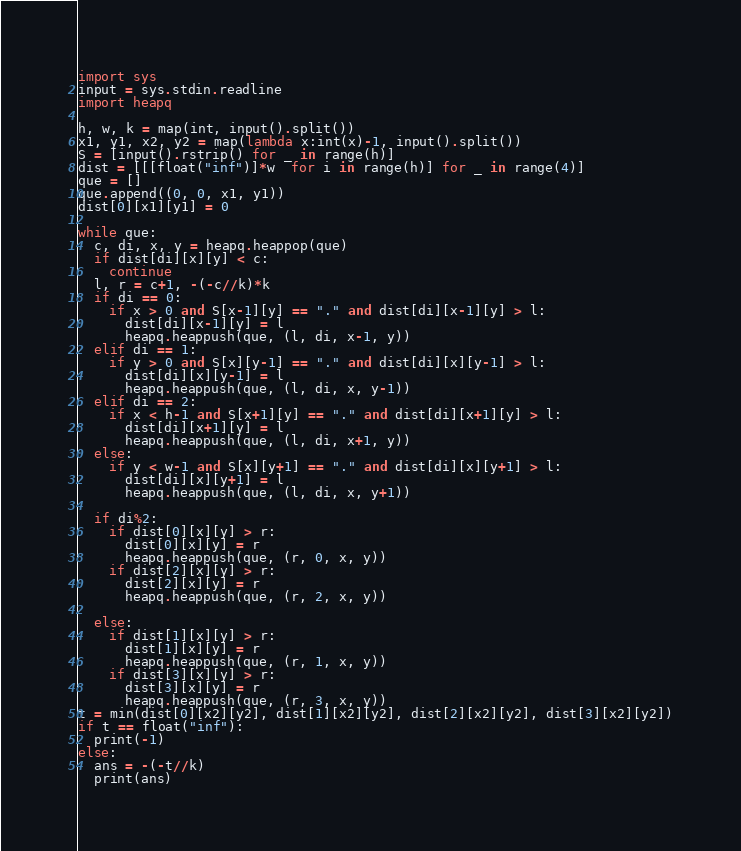<code> <loc_0><loc_0><loc_500><loc_500><_Python_>import sys
input = sys.stdin.readline
import heapq

h, w, k = map(int, input().split())
x1, y1, x2, y2 = map(lambda x:int(x)-1, input().split())
S = [input().rstrip() for _ in range(h)]
dist = [[[float("inf")]*w  for i in range(h)] for _ in range(4)]
que = []
que.append((0, 0, x1, y1))
dist[0][x1][y1] = 0
  
while que:
  c, di, x, y = heapq.heappop(que)
  if dist[di][x][y] < c:
    continue
  l, r = c+1, -(-c//k)*k
  if di == 0:
    if x > 0 and S[x-1][y] == "." and dist[di][x-1][y] > l:
      dist[di][x-1][y] = l
      heapq.heappush(que, (l, di, x-1, y))
  elif di == 1:
    if y > 0 and S[x][y-1] == "." and dist[di][x][y-1] > l:
      dist[di][x][y-1] = l
      heapq.heappush(que, (l, di, x, y-1))
  elif di == 2:
    if x < h-1 and S[x+1][y] == "." and dist[di][x+1][y] > l:
      dist[di][x+1][y] = l
      heapq.heappush(que, (l, di, x+1, y))
  else:
    if y < w-1 and S[x][y+1] == "." and dist[di][x][y+1] > l:
      dist[di][x][y+1] = l
      heapq.heappush(que, (l, di, x, y+1))
      
  if di%2:
    if dist[0][x][y] > r:
      dist[0][x][y] = r
      heapq.heappush(que, (r, 0, x, y))
    if dist[2][x][y] > r:
      dist[2][x][y] = r
      heapq.heappush(que, (r, 2, x, y))
    
  else:
    if dist[1][x][y] > r:
      dist[1][x][y] = r
      heapq.heappush(que, (r, 1, x, y))
    if dist[3][x][y] > r:
      dist[3][x][y] = r
      heapq.heappush(que, (r, 3, x, y))
t = min(dist[0][x2][y2], dist[1][x2][y2], dist[2][x2][y2], dist[3][x2][y2])
if t == float("inf"):
  print(-1)
else:
  ans = -(-t//k)
  print(ans)</code> 